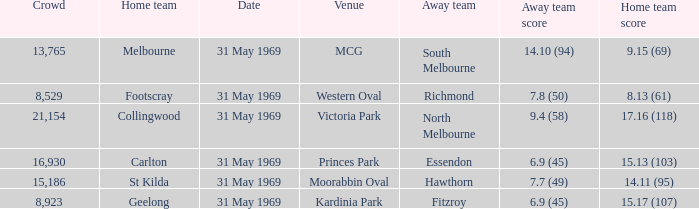Who was the home team in the game where North Melbourne was the away team? 17.16 (118). 